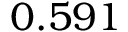Convert formula to latex. <formula><loc_0><loc_0><loc_500><loc_500>0 . 5 9 1</formula> 